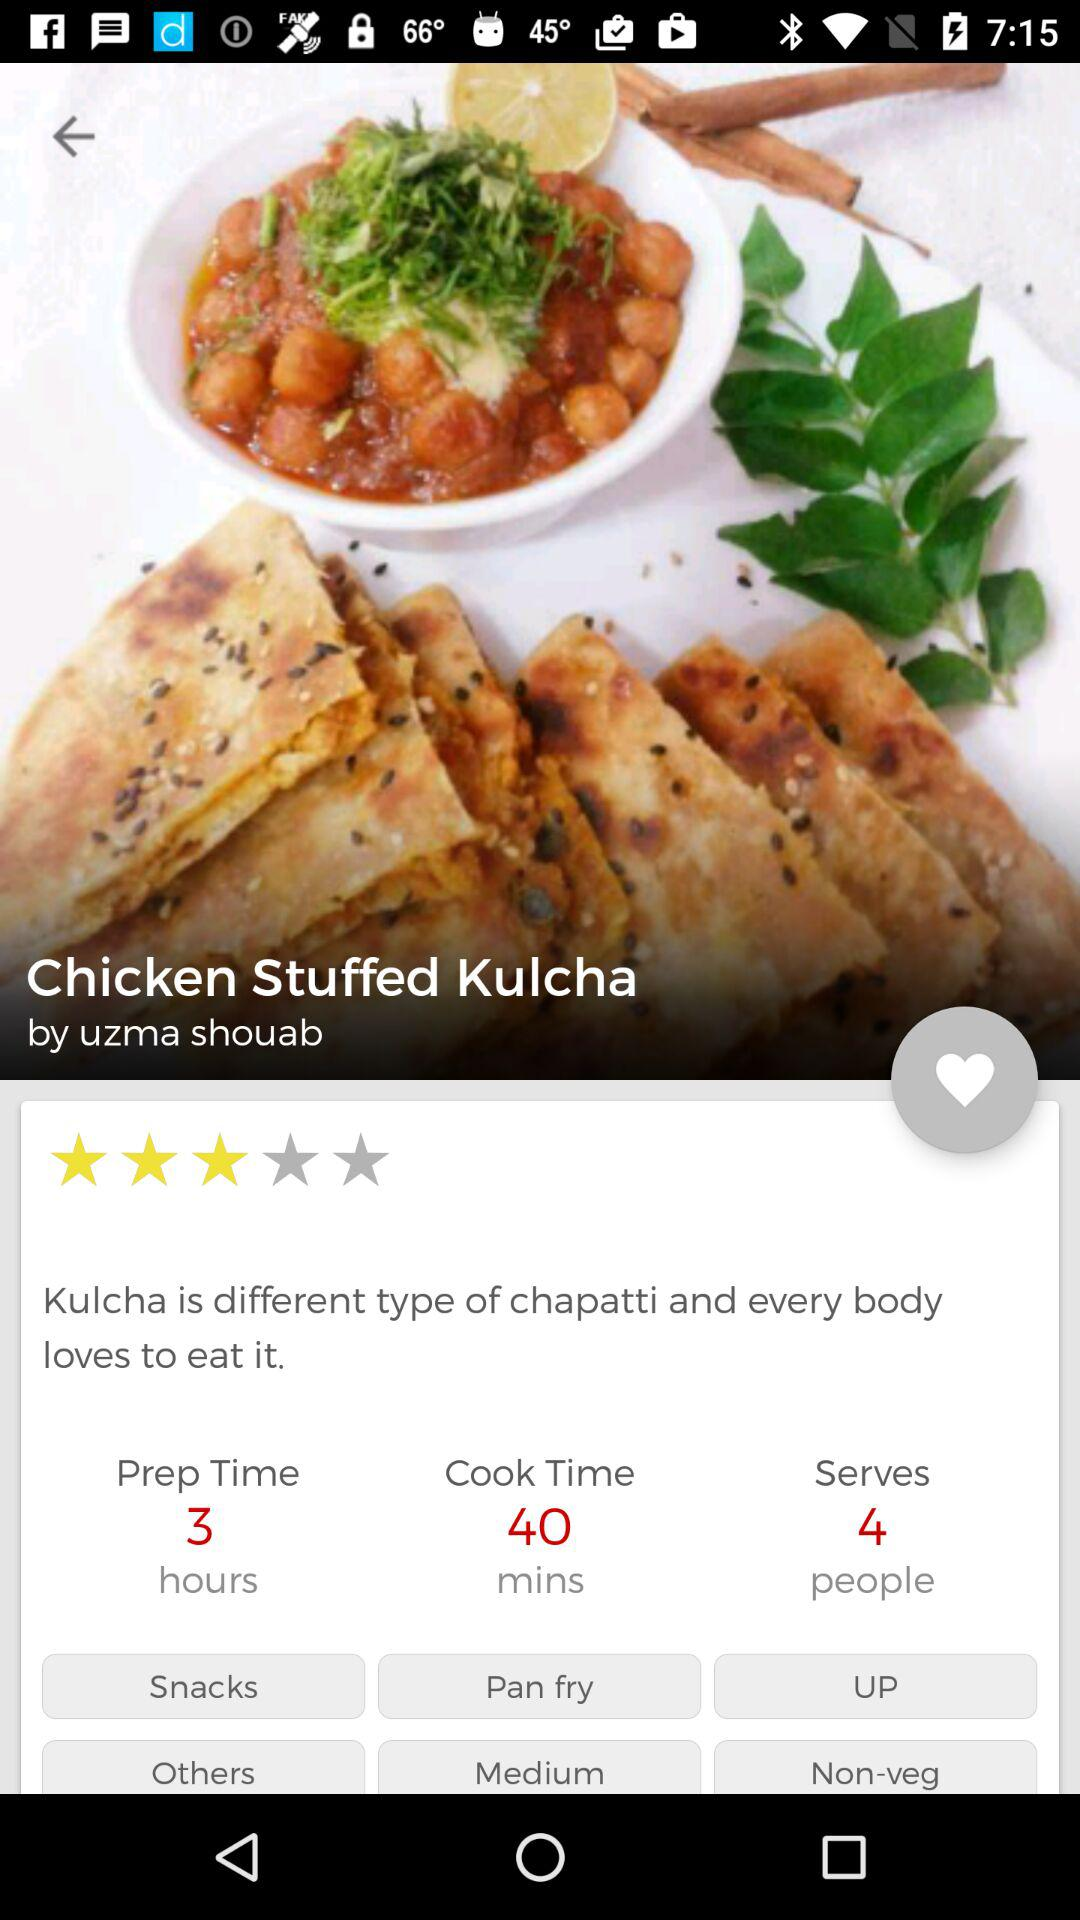What is the rating of the dish? The rating is 3 stars. 